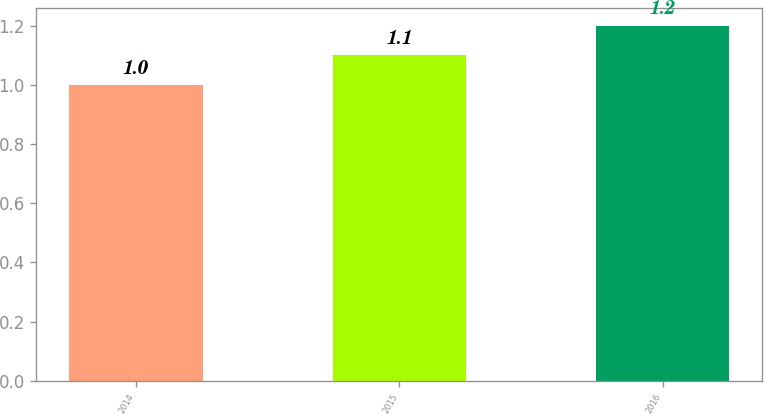Convert chart. <chart><loc_0><loc_0><loc_500><loc_500><bar_chart><fcel>2014<fcel>2015<fcel>2016<nl><fcel>1<fcel>1.1<fcel>1.2<nl></chart> 